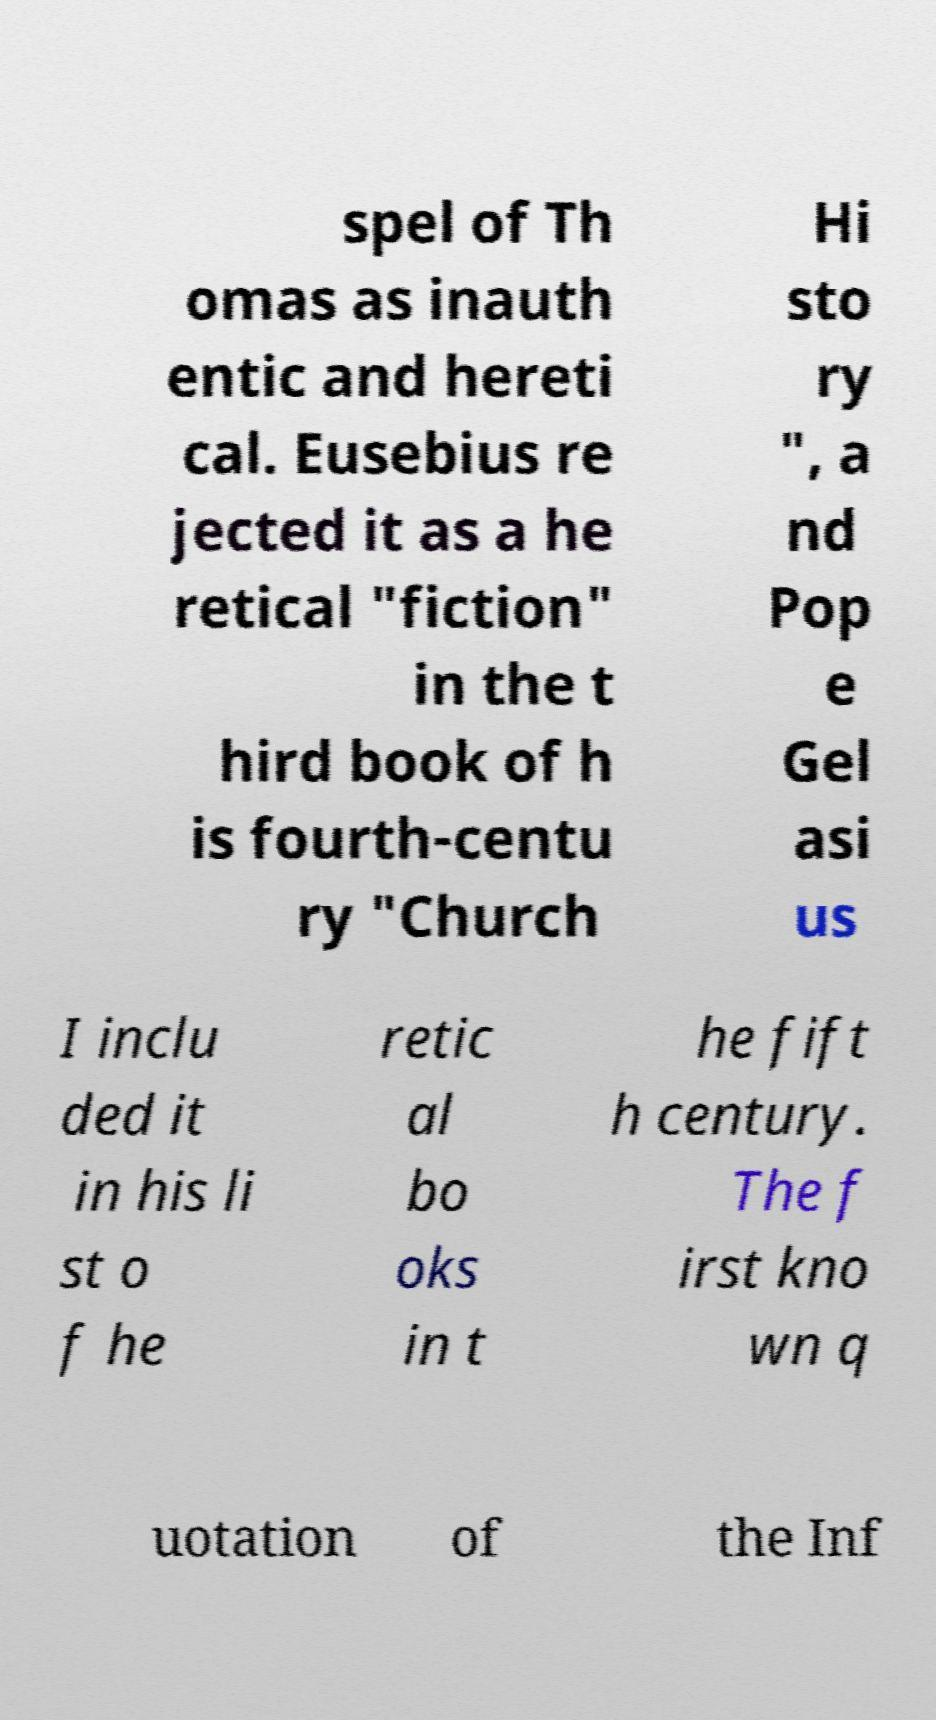Please identify and transcribe the text found in this image. spel of Th omas as inauth entic and hereti cal. Eusebius re jected it as a he retical "fiction" in the t hird book of h is fourth-centu ry "Church Hi sto ry ", a nd Pop e Gel asi us I inclu ded it in his li st o f he retic al bo oks in t he fift h century. The f irst kno wn q uotation of the Inf 